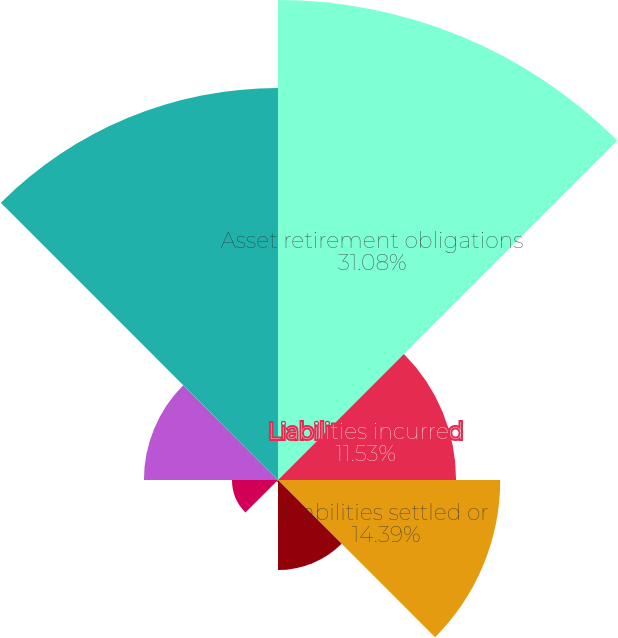Convert chart. <chart><loc_0><loc_0><loc_500><loc_500><pie_chart><fcel>Asset retirement obligations<fcel>Liabilities incurred<fcel>Liabilities settled or<fcel>Accretion expense<fcel>Revisions of estimated<fcel>Foreign currency translation<fcel>Less current obligations<fcel>Long-term obligations at<nl><fcel>31.08%<fcel>11.53%<fcel>14.39%<fcel>5.83%<fcel>0.13%<fcel>2.98%<fcel>8.68%<fcel>25.38%<nl></chart> 